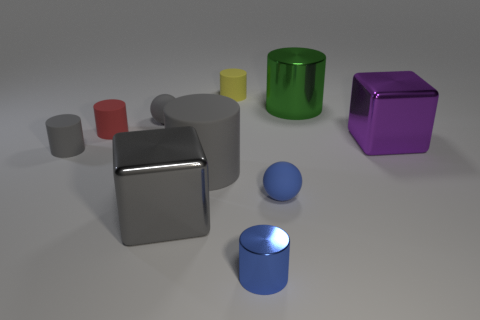Subtract all red cylinders. How many cylinders are left? 5 Subtract all small red matte cylinders. How many cylinders are left? 5 Subtract all purple cylinders. Subtract all purple blocks. How many cylinders are left? 6 Subtract all blocks. How many objects are left? 8 Subtract 0 cyan cylinders. How many objects are left? 10 Subtract all blue metallic objects. Subtract all gray shiny things. How many objects are left? 8 Add 1 big cylinders. How many big cylinders are left? 3 Add 8 blue rubber objects. How many blue rubber objects exist? 9 